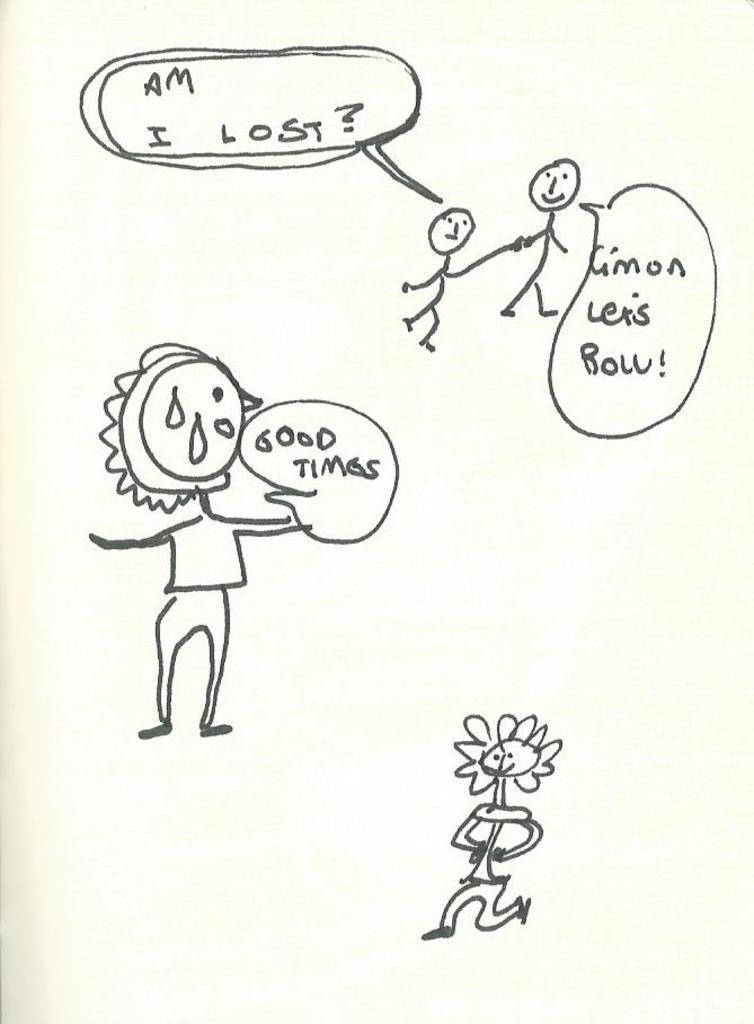How would you summarize this image in a sentence or two? In this image, we can see there are drawings of persons and there are texts. And the background is white in color. 